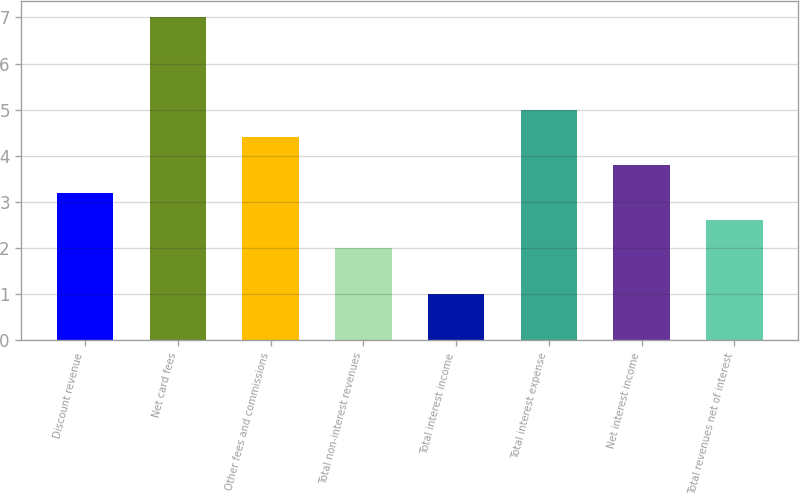Convert chart to OTSL. <chart><loc_0><loc_0><loc_500><loc_500><bar_chart><fcel>Discount revenue<fcel>Net card fees<fcel>Other fees and commissions<fcel>Total non-interest revenues<fcel>Total interest income<fcel>Total interest expense<fcel>Net interest income<fcel>Total revenues net of interest<nl><fcel>3.2<fcel>7<fcel>4.4<fcel>2<fcel>1<fcel>5<fcel>3.8<fcel>2.6<nl></chart> 